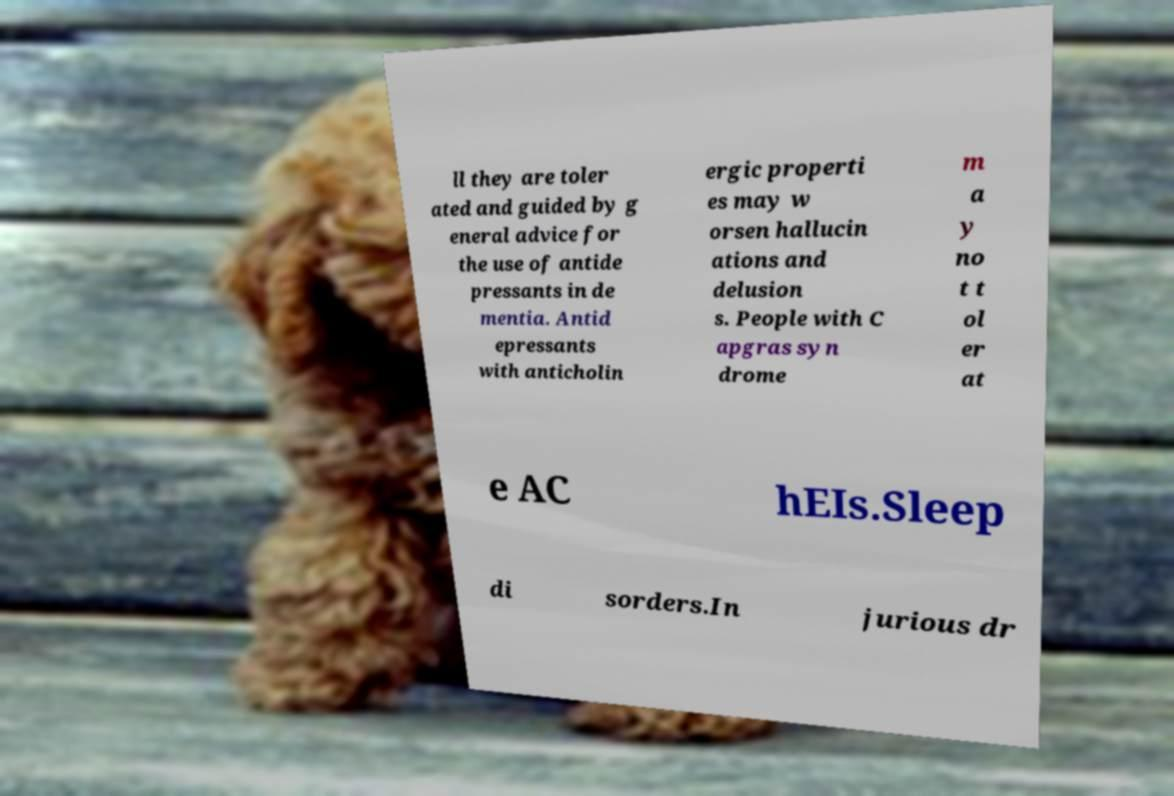Please identify and transcribe the text found in this image. ll they are toler ated and guided by g eneral advice for the use of antide pressants in de mentia. Antid epressants with anticholin ergic properti es may w orsen hallucin ations and delusion s. People with C apgras syn drome m a y no t t ol er at e AC hEIs.Sleep di sorders.In jurious dr 